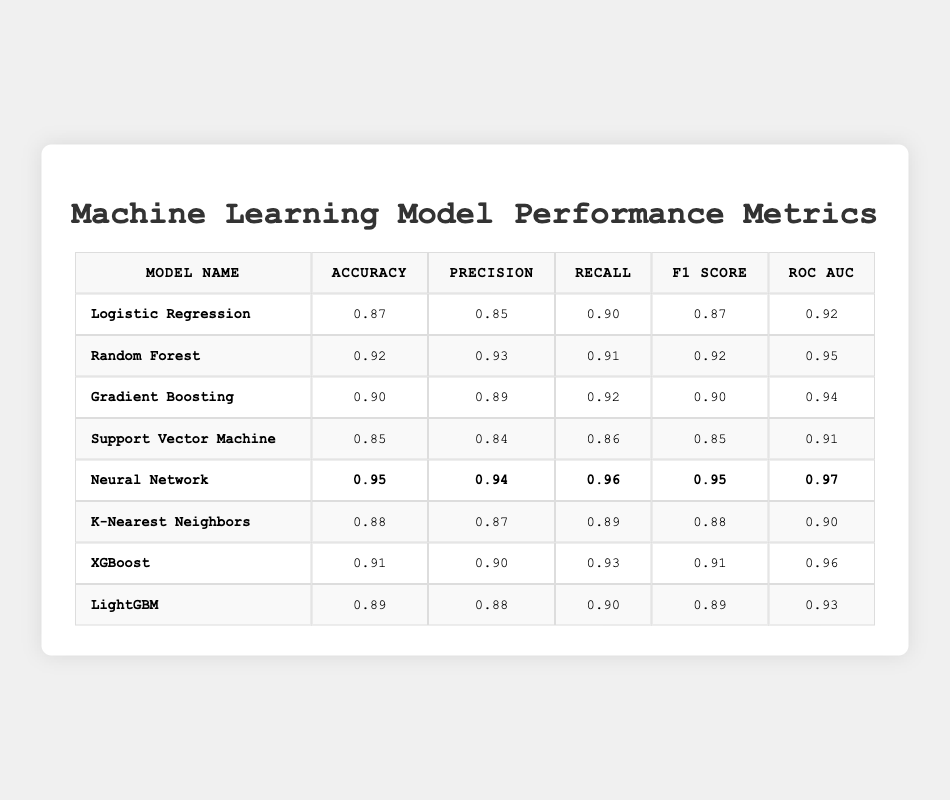What is the accuracy of the Neural Network model? The accuracy of the Neural Network is stated directly in the table under the "Accuracy" column, which lists 0.95.
Answer: 0.95 Which model has the highest ROC AUC score? The table shows that the Neural Network has a ROC AUC score of 0.97, which is the highest value presented in the table.
Answer: Neural Network What is the difference in precision between Random Forest and Logistic Regression? The precision for Random Forest is 0.93 and for Logistic Regression is 0.85. The difference is calculated as 0.93 - 0.85 = 0.08.
Answer: 0.08 Is the F1 score for Gradient Boosting higher than that for K-Nearest Neighbors? The F1 score for Gradient Boosting is 0.90, while for K-Nearest Neighbors it is 0.88. Since 0.90 is greater than 0.88, the statement is true.
Answer: Yes What is the average accuracy of the models listed in the table? To find the average accuracy, we sum all accuracy values: 0.87 + 0.92 + 0.90 + 0.85 + 0.95 + 0.88 + 0.91 + 0.89 = 7.17. Then divide by the number of models (8): 7.17 / 8 = 0.89625.
Answer: 0.89625 Which model has the lowest precision? By examining the precision values in the table, we see that Support Vector Machine has the lowest precision of 0.84.
Answer: Support Vector Machine If we rank the models based on F1 score, which model ranks third? The F1 scores in descending order are: Neural Network (0.95), Random Forest (0.92), Gradient Boosting (0.90). Thus, the third-ranked model is Gradient Boosting.
Answer: Gradient Boosting What is the combined recall of Logistic Regression and K-Nearest Neighbors? The recall for Logistic Regression is 0.90 and for K-Nearest Neighbors it is 0.89. The combined recall is calculated by adding these two values: 0.90 + 0.89 = 1.79.
Answer: 1.79 Is the accuracy of LightGBM above 0.90? The accuracy of LightGBM is 0.89, which is not above 0.90. Therefore, the statement is false.
Answer: No What model has the closest values for Precision and Recall? Looking at the precision and recall values, K-Nearest Neighbors has a precision of 0.87 and a recall of 0.89, which are the closest values among all models.
Answer: K-Nearest Neighbors 